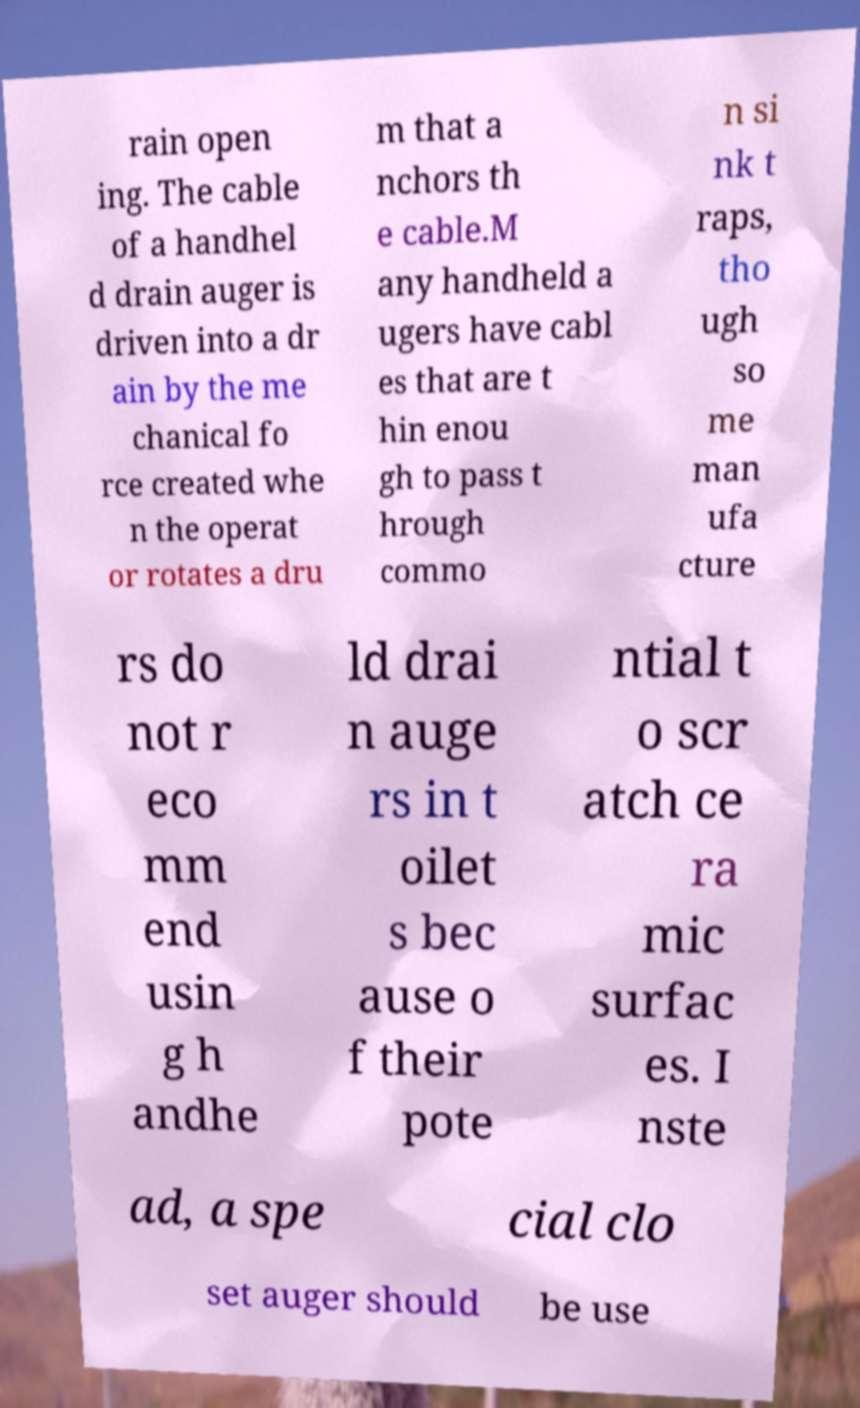Can you read and provide the text displayed in the image?This photo seems to have some interesting text. Can you extract and type it out for me? rain open ing. The cable of a handhel d drain auger is driven into a dr ain by the me chanical fo rce created whe n the operat or rotates a dru m that a nchors th e cable.M any handheld a ugers have cabl es that are t hin enou gh to pass t hrough commo n si nk t raps, tho ugh so me man ufa cture rs do not r eco mm end usin g h andhe ld drai n auge rs in t oilet s bec ause o f their pote ntial t o scr atch ce ra mic surfac es. I nste ad, a spe cial clo set auger should be use 